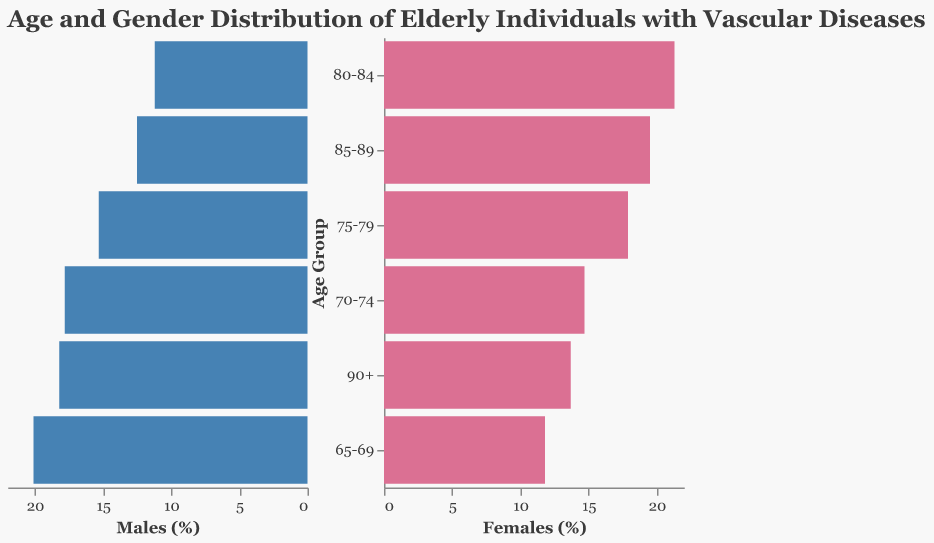What is the title of the figure? The title of the figure is displayed at the top, with the text "Age and Gender Distribution of Elderly Individuals with Vascular Diseases".
Answer: Age and Gender Distribution of Elderly Individuals with Vascular Diseases What are the age groups listed in the figure? The age groups appear on the y-axis of both sides of the pyramid, they are "65-69", "70-74", "75-79", "80-84", "85-89", and "90+".
Answer: 65-69, 70-74, 75-79, 80-84, 85-89, 90+ Which age group has the highest percentage of males? To find this, you need to look at the negative x-axis of the left side of the pyramid and identify the age group with the longest bar. The "80-84" age group has the highest percentage of males at 20.1%.
Answer: 80-84 Which age group has more females compared to males? By comparing the lengths of the bars for males and females in each age group, the "80-84" and "85-89" age groups have more females compared to males, as the female bars are longer than the male bars.
Answer: 80-84, 85-89 What is the combined percentage of males and females in the "70-74" age group? Summing the percentages of males and females in the "70-74" age group gives 15.3% for males and 14.7% for females. Thus, the combined percentage is 15.3 + 14.7 = 30%.
Answer: 30% Which gender has a higher proportion in the "75-79" age group? By comparing the lengths of the bars for the "75-79" age group, males have a proportion of 18.2%, and females have 17.9%. The males have a slightly higher percentage.
Answer: Males What is the percentage difference between males and females in the "85-89" age group? Subtract the percentage of males (17.8%) from the percentage of females (19.5%) in the "85-89" age group to find the difference: 19.5 - 17.8 = 1.7%.
Answer: 1.7% In which age group do females have the highest percentage? Look for the longest bar on the right side of the pyramid, representing females. The "80-84" age group has the highest percentage of females at 21.3%.
Answer: 80-84 